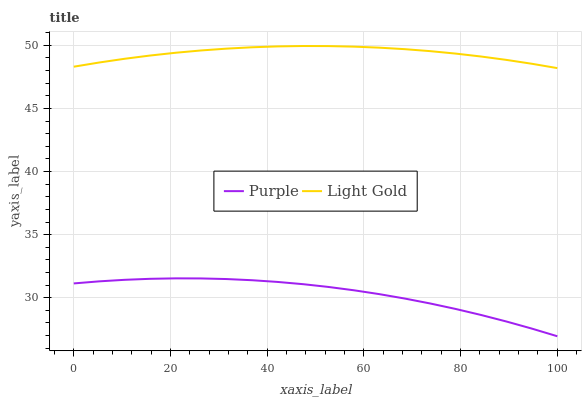Does Light Gold have the minimum area under the curve?
Answer yes or no. No. Is Light Gold the roughest?
Answer yes or no. No. Does Light Gold have the lowest value?
Answer yes or no. No. Is Purple less than Light Gold?
Answer yes or no. Yes. Is Light Gold greater than Purple?
Answer yes or no. Yes. Does Purple intersect Light Gold?
Answer yes or no. No. 